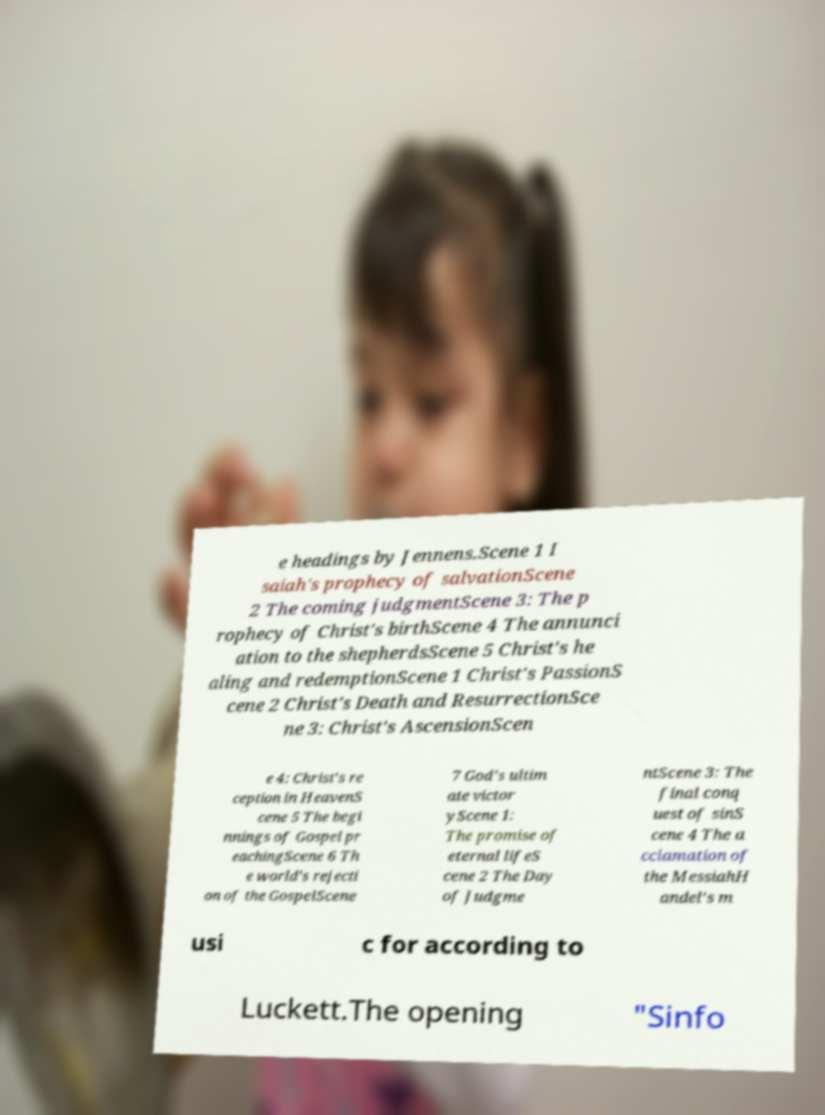Can you read and provide the text displayed in the image?This photo seems to have some interesting text. Can you extract and type it out for me? e headings by Jennens.Scene 1 I saiah's prophecy of salvationScene 2 The coming judgmentScene 3: The p rophecy of Christ's birthScene 4 The annunci ation to the shepherdsScene 5 Christ's he aling and redemptionScene 1 Christ's PassionS cene 2 Christ's Death and ResurrectionSce ne 3: Christ's AscensionScen e 4: Christ's re ception in HeavenS cene 5 The begi nnings of Gospel pr eachingScene 6 Th e world's rejecti on of the GospelScene 7 God's ultim ate victor yScene 1: The promise of eternal lifeS cene 2 The Day of Judgme ntScene 3: The final conq uest of sinS cene 4 The a cclamation of the MessiahH andel's m usi c for according to Luckett.The opening "Sinfo 